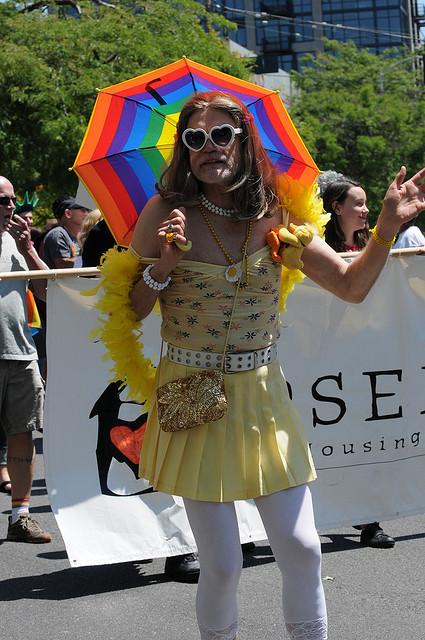What does the man use the umbrella for?

Choices:
A) hail
B) rain
C) decoration
D) shade shade 